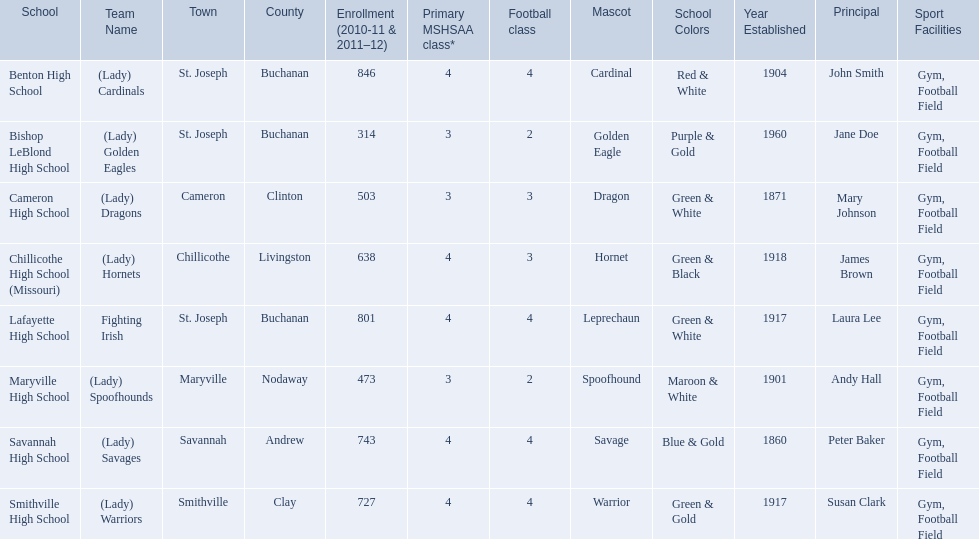What school in midland empire conference has 846 students enrolled? Benton High School. What school has 314 students enrolled? Bishop LeBlond High School. What school had 638 students enrolled? Chillicothe High School (Missouri). 